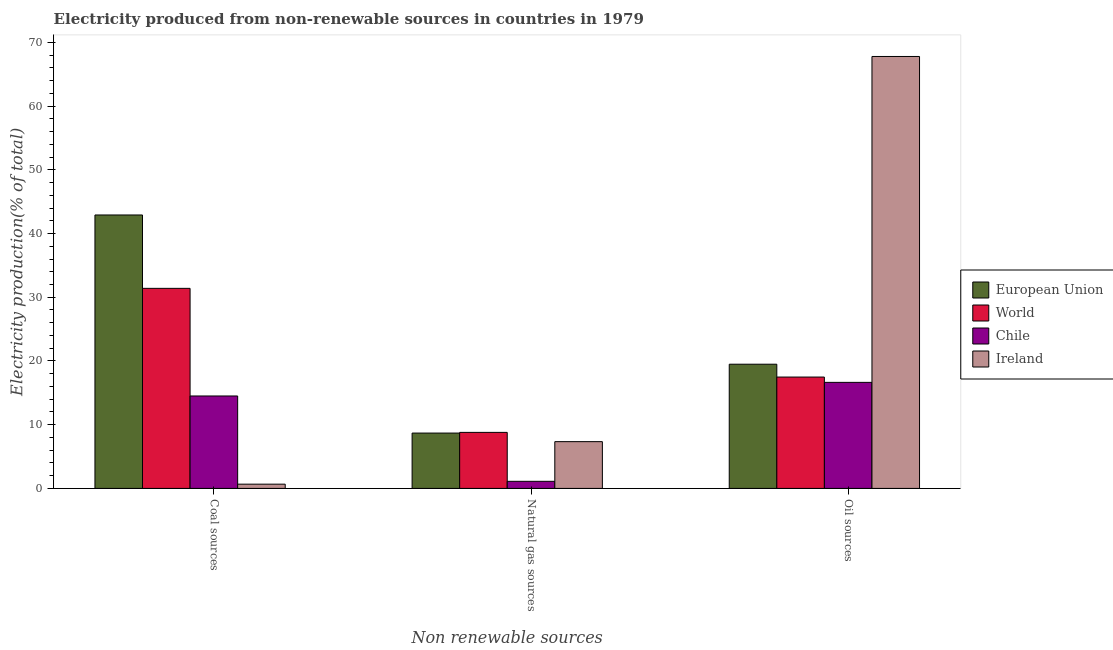How many different coloured bars are there?
Provide a succinct answer. 4. How many groups of bars are there?
Your answer should be very brief. 3. Are the number of bars on each tick of the X-axis equal?
Your answer should be very brief. Yes. How many bars are there on the 3rd tick from the right?
Provide a short and direct response. 4. What is the label of the 2nd group of bars from the left?
Your answer should be very brief. Natural gas sources. What is the percentage of electricity produced by coal in Ireland?
Offer a very short reply. 0.67. Across all countries, what is the maximum percentage of electricity produced by natural gas?
Your answer should be very brief. 8.79. Across all countries, what is the minimum percentage of electricity produced by oil sources?
Provide a short and direct response. 16.64. In which country was the percentage of electricity produced by natural gas maximum?
Your response must be concise. World. What is the total percentage of electricity produced by natural gas in the graph?
Make the answer very short. 25.93. What is the difference between the percentage of electricity produced by natural gas in Chile and that in European Union?
Keep it short and to the point. -7.57. What is the difference between the percentage of electricity produced by coal in World and the percentage of electricity produced by natural gas in European Union?
Your response must be concise. 22.71. What is the average percentage of electricity produced by natural gas per country?
Give a very brief answer. 6.48. What is the difference between the percentage of electricity produced by coal and percentage of electricity produced by oil sources in Ireland?
Your answer should be very brief. -67.11. In how many countries, is the percentage of electricity produced by natural gas greater than 16 %?
Make the answer very short. 0. What is the ratio of the percentage of electricity produced by coal in Chile to that in Ireland?
Ensure brevity in your answer.  21.74. Is the difference between the percentage of electricity produced by oil sources in Chile and World greater than the difference between the percentage of electricity produced by natural gas in Chile and World?
Keep it short and to the point. Yes. What is the difference between the highest and the second highest percentage of electricity produced by oil sources?
Your answer should be compact. 48.29. What is the difference between the highest and the lowest percentage of electricity produced by oil sources?
Your answer should be very brief. 51.14. In how many countries, is the percentage of electricity produced by coal greater than the average percentage of electricity produced by coal taken over all countries?
Give a very brief answer. 2. What does the 1st bar from the right in Oil sources represents?
Provide a short and direct response. Ireland. Is it the case that in every country, the sum of the percentage of electricity produced by coal and percentage of electricity produced by natural gas is greater than the percentage of electricity produced by oil sources?
Keep it short and to the point. No. How many bars are there?
Ensure brevity in your answer.  12. What is the difference between two consecutive major ticks on the Y-axis?
Keep it short and to the point. 10. Does the graph contain any zero values?
Make the answer very short. No. Does the graph contain grids?
Provide a succinct answer. No. Where does the legend appear in the graph?
Your answer should be compact. Center right. How many legend labels are there?
Your answer should be very brief. 4. How are the legend labels stacked?
Your response must be concise. Vertical. What is the title of the graph?
Provide a short and direct response. Electricity produced from non-renewable sources in countries in 1979. What is the label or title of the X-axis?
Your answer should be compact. Non renewable sources. What is the label or title of the Y-axis?
Provide a short and direct response. Electricity production(% of total). What is the Electricity production(% of total) in European Union in Coal sources?
Your response must be concise. 42.91. What is the Electricity production(% of total) of World in Coal sources?
Give a very brief answer. 31.39. What is the Electricity production(% of total) in Chile in Coal sources?
Offer a very short reply. 14.51. What is the Electricity production(% of total) of Ireland in Coal sources?
Give a very brief answer. 0.67. What is the Electricity production(% of total) of European Union in Natural gas sources?
Ensure brevity in your answer.  8.69. What is the Electricity production(% of total) in World in Natural gas sources?
Provide a succinct answer. 8.79. What is the Electricity production(% of total) in Chile in Natural gas sources?
Keep it short and to the point. 1.11. What is the Electricity production(% of total) in Ireland in Natural gas sources?
Offer a terse response. 7.34. What is the Electricity production(% of total) in European Union in Oil sources?
Ensure brevity in your answer.  19.49. What is the Electricity production(% of total) in World in Oil sources?
Offer a very short reply. 17.48. What is the Electricity production(% of total) of Chile in Oil sources?
Give a very brief answer. 16.64. What is the Electricity production(% of total) in Ireland in Oil sources?
Keep it short and to the point. 67.78. Across all Non renewable sources, what is the maximum Electricity production(% of total) in European Union?
Your answer should be compact. 42.91. Across all Non renewable sources, what is the maximum Electricity production(% of total) of World?
Your answer should be very brief. 31.39. Across all Non renewable sources, what is the maximum Electricity production(% of total) of Chile?
Offer a terse response. 16.64. Across all Non renewable sources, what is the maximum Electricity production(% of total) in Ireland?
Your response must be concise. 67.78. Across all Non renewable sources, what is the minimum Electricity production(% of total) in European Union?
Make the answer very short. 8.69. Across all Non renewable sources, what is the minimum Electricity production(% of total) in World?
Offer a very short reply. 8.79. Across all Non renewable sources, what is the minimum Electricity production(% of total) in Chile?
Your answer should be very brief. 1.11. Across all Non renewable sources, what is the minimum Electricity production(% of total) of Ireland?
Your response must be concise. 0.67. What is the total Electricity production(% of total) in European Union in the graph?
Provide a short and direct response. 71.09. What is the total Electricity production(% of total) of World in the graph?
Your answer should be very brief. 57.66. What is the total Electricity production(% of total) of Chile in the graph?
Your answer should be very brief. 32.26. What is the total Electricity production(% of total) of Ireland in the graph?
Provide a succinct answer. 75.79. What is the difference between the Electricity production(% of total) in European Union in Coal sources and that in Natural gas sources?
Make the answer very short. 34.22. What is the difference between the Electricity production(% of total) of World in Coal sources and that in Natural gas sources?
Offer a terse response. 22.6. What is the difference between the Electricity production(% of total) of Chile in Coal sources and that in Natural gas sources?
Your answer should be compact. 13.39. What is the difference between the Electricity production(% of total) in Ireland in Coal sources and that in Natural gas sources?
Give a very brief answer. -6.67. What is the difference between the Electricity production(% of total) in European Union in Coal sources and that in Oil sources?
Your answer should be compact. 23.42. What is the difference between the Electricity production(% of total) in World in Coal sources and that in Oil sources?
Offer a terse response. 13.92. What is the difference between the Electricity production(% of total) in Chile in Coal sources and that in Oil sources?
Keep it short and to the point. -2.14. What is the difference between the Electricity production(% of total) of Ireland in Coal sources and that in Oil sources?
Give a very brief answer. -67.11. What is the difference between the Electricity production(% of total) of European Union in Natural gas sources and that in Oil sources?
Offer a very short reply. -10.8. What is the difference between the Electricity production(% of total) of World in Natural gas sources and that in Oil sources?
Your answer should be very brief. -8.68. What is the difference between the Electricity production(% of total) in Chile in Natural gas sources and that in Oil sources?
Offer a very short reply. -15.53. What is the difference between the Electricity production(% of total) of Ireland in Natural gas sources and that in Oil sources?
Offer a terse response. -60.44. What is the difference between the Electricity production(% of total) in European Union in Coal sources and the Electricity production(% of total) in World in Natural gas sources?
Your response must be concise. 34.12. What is the difference between the Electricity production(% of total) of European Union in Coal sources and the Electricity production(% of total) of Chile in Natural gas sources?
Keep it short and to the point. 41.8. What is the difference between the Electricity production(% of total) of European Union in Coal sources and the Electricity production(% of total) of Ireland in Natural gas sources?
Your answer should be very brief. 35.57. What is the difference between the Electricity production(% of total) of World in Coal sources and the Electricity production(% of total) of Chile in Natural gas sources?
Keep it short and to the point. 30.28. What is the difference between the Electricity production(% of total) of World in Coal sources and the Electricity production(% of total) of Ireland in Natural gas sources?
Your answer should be very brief. 24.05. What is the difference between the Electricity production(% of total) in Chile in Coal sources and the Electricity production(% of total) in Ireland in Natural gas sources?
Give a very brief answer. 7.16. What is the difference between the Electricity production(% of total) of European Union in Coal sources and the Electricity production(% of total) of World in Oil sources?
Keep it short and to the point. 25.43. What is the difference between the Electricity production(% of total) in European Union in Coal sources and the Electricity production(% of total) in Chile in Oil sources?
Provide a short and direct response. 26.27. What is the difference between the Electricity production(% of total) in European Union in Coal sources and the Electricity production(% of total) in Ireland in Oil sources?
Your answer should be very brief. -24.87. What is the difference between the Electricity production(% of total) of World in Coal sources and the Electricity production(% of total) of Chile in Oil sources?
Your answer should be compact. 14.75. What is the difference between the Electricity production(% of total) in World in Coal sources and the Electricity production(% of total) in Ireland in Oil sources?
Give a very brief answer. -36.39. What is the difference between the Electricity production(% of total) in Chile in Coal sources and the Electricity production(% of total) in Ireland in Oil sources?
Your response must be concise. -53.28. What is the difference between the Electricity production(% of total) of European Union in Natural gas sources and the Electricity production(% of total) of World in Oil sources?
Offer a very short reply. -8.79. What is the difference between the Electricity production(% of total) of European Union in Natural gas sources and the Electricity production(% of total) of Chile in Oil sources?
Give a very brief answer. -7.96. What is the difference between the Electricity production(% of total) in European Union in Natural gas sources and the Electricity production(% of total) in Ireland in Oil sources?
Give a very brief answer. -59.1. What is the difference between the Electricity production(% of total) in World in Natural gas sources and the Electricity production(% of total) in Chile in Oil sources?
Offer a very short reply. -7.85. What is the difference between the Electricity production(% of total) in World in Natural gas sources and the Electricity production(% of total) in Ireland in Oil sources?
Give a very brief answer. -58.99. What is the difference between the Electricity production(% of total) in Chile in Natural gas sources and the Electricity production(% of total) in Ireland in Oil sources?
Provide a short and direct response. -66.67. What is the average Electricity production(% of total) in European Union per Non renewable sources?
Offer a very short reply. 23.7. What is the average Electricity production(% of total) in World per Non renewable sources?
Your answer should be compact. 19.22. What is the average Electricity production(% of total) in Chile per Non renewable sources?
Offer a terse response. 10.75. What is the average Electricity production(% of total) of Ireland per Non renewable sources?
Provide a succinct answer. 25.26. What is the difference between the Electricity production(% of total) of European Union and Electricity production(% of total) of World in Coal sources?
Provide a short and direct response. 11.52. What is the difference between the Electricity production(% of total) in European Union and Electricity production(% of total) in Chile in Coal sources?
Give a very brief answer. 28.4. What is the difference between the Electricity production(% of total) of European Union and Electricity production(% of total) of Ireland in Coal sources?
Ensure brevity in your answer.  42.24. What is the difference between the Electricity production(% of total) in World and Electricity production(% of total) in Chile in Coal sources?
Provide a succinct answer. 16.89. What is the difference between the Electricity production(% of total) in World and Electricity production(% of total) in Ireland in Coal sources?
Your answer should be very brief. 30.73. What is the difference between the Electricity production(% of total) of Chile and Electricity production(% of total) of Ireland in Coal sources?
Offer a terse response. 13.84. What is the difference between the Electricity production(% of total) of European Union and Electricity production(% of total) of World in Natural gas sources?
Keep it short and to the point. -0.11. What is the difference between the Electricity production(% of total) in European Union and Electricity production(% of total) in Chile in Natural gas sources?
Your answer should be very brief. 7.57. What is the difference between the Electricity production(% of total) of European Union and Electricity production(% of total) of Ireland in Natural gas sources?
Offer a terse response. 1.35. What is the difference between the Electricity production(% of total) in World and Electricity production(% of total) in Chile in Natural gas sources?
Offer a terse response. 7.68. What is the difference between the Electricity production(% of total) of World and Electricity production(% of total) of Ireland in Natural gas sources?
Make the answer very short. 1.45. What is the difference between the Electricity production(% of total) in Chile and Electricity production(% of total) in Ireland in Natural gas sources?
Provide a succinct answer. -6.23. What is the difference between the Electricity production(% of total) in European Union and Electricity production(% of total) in World in Oil sources?
Offer a terse response. 2.01. What is the difference between the Electricity production(% of total) in European Union and Electricity production(% of total) in Chile in Oil sources?
Provide a succinct answer. 2.85. What is the difference between the Electricity production(% of total) of European Union and Electricity production(% of total) of Ireland in Oil sources?
Your answer should be compact. -48.29. What is the difference between the Electricity production(% of total) in World and Electricity production(% of total) in Chile in Oil sources?
Provide a succinct answer. 0.83. What is the difference between the Electricity production(% of total) of World and Electricity production(% of total) of Ireland in Oil sources?
Make the answer very short. -50.31. What is the difference between the Electricity production(% of total) in Chile and Electricity production(% of total) in Ireland in Oil sources?
Give a very brief answer. -51.14. What is the ratio of the Electricity production(% of total) in European Union in Coal sources to that in Natural gas sources?
Offer a very short reply. 4.94. What is the ratio of the Electricity production(% of total) in World in Coal sources to that in Natural gas sources?
Your answer should be compact. 3.57. What is the ratio of the Electricity production(% of total) of Chile in Coal sources to that in Natural gas sources?
Your answer should be very brief. 13.02. What is the ratio of the Electricity production(% of total) of Ireland in Coal sources to that in Natural gas sources?
Offer a terse response. 0.09. What is the ratio of the Electricity production(% of total) of European Union in Coal sources to that in Oil sources?
Your response must be concise. 2.2. What is the ratio of the Electricity production(% of total) in World in Coal sources to that in Oil sources?
Offer a very short reply. 1.8. What is the ratio of the Electricity production(% of total) of Chile in Coal sources to that in Oil sources?
Your answer should be compact. 0.87. What is the ratio of the Electricity production(% of total) in Ireland in Coal sources to that in Oil sources?
Offer a very short reply. 0.01. What is the ratio of the Electricity production(% of total) in European Union in Natural gas sources to that in Oil sources?
Offer a very short reply. 0.45. What is the ratio of the Electricity production(% of total) of World in Natural gas sources to that in Oil sources?
Give a very brief answer. 0.5. What is the ratio of the Electricity production(% of total) of Chile in Natural gas sources to that in Oil sources?
Your answer should be compact. 0.07. What is the ratio of the Electricity production(% of total) in Ireland in Natural gas sources to that in Oil sources?
Provide a short and direct response. 0.11. What is the difference between the highest and the second highest Electricity production(% of total) of European Union?
Your answer should be compact. 23.42. What is the difference between the highest and the second highest Electricity production(% of total) in World?
Keep it short and to the point. 13.92. What is the difference between the highest and the second highest Electricity production(% of total) of Chile?
Offer a terse response. 2.14. What is the difference between the highest and the second highest Electricity production(% of total) in Ireland?
Your answer should be very brief. 60.44. What is the difference between the highest and the lowest Electricity production(% of total) in European Union?
Your answer should be compact. 34.22. What is the difference between the highest and the lowest Electricity production(% of total) of World?
Offer a terse response. 22.6. What is the difference between the highest and the lowest Electricity production(% of total) in Chile?
Your answer should be compact. 15.53. What is the difference between the highest and the lowest Electricity production(% of total) in Ireland?
Provide a short and direct response. 67.11. 